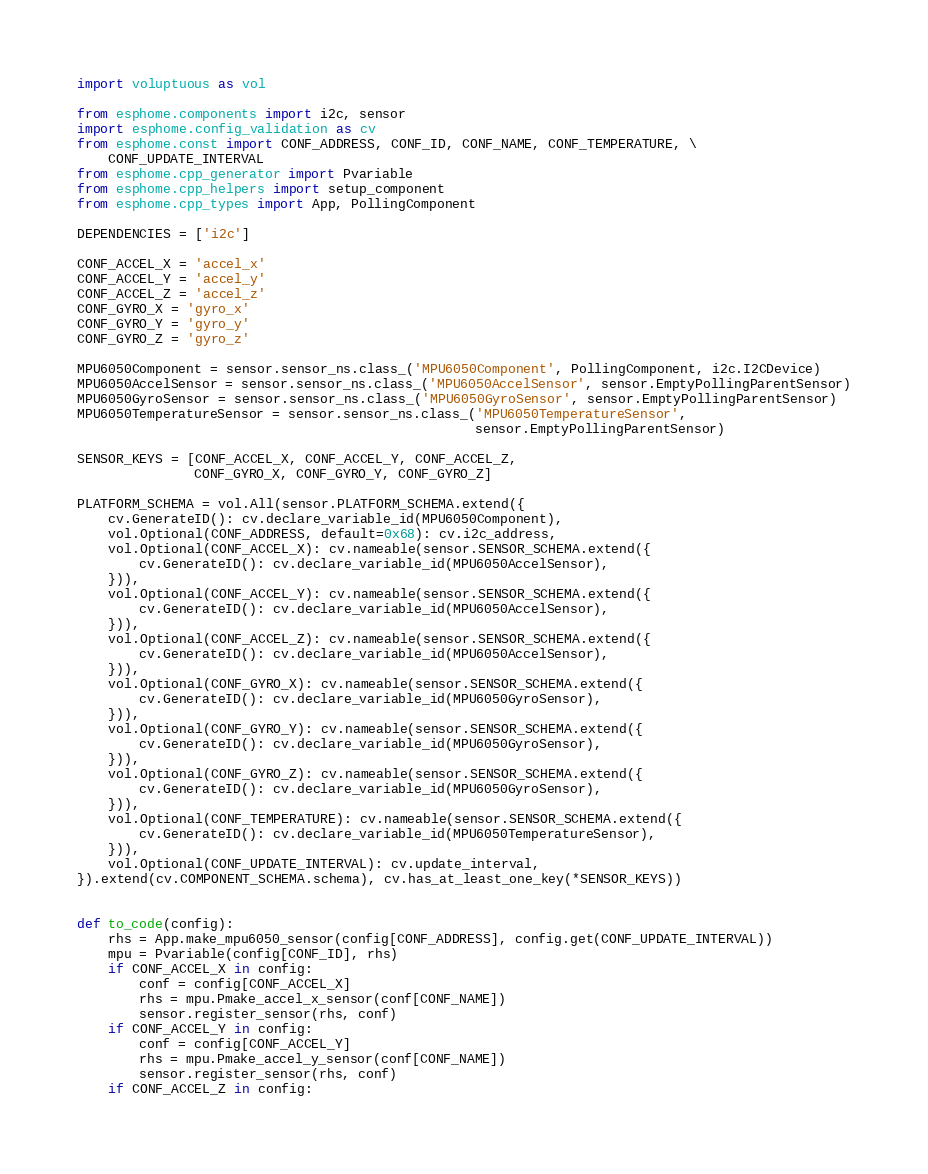<code> <loc_0><loc_0><loc_500><loc_500><_Python_>import voluptuous as vol

from esphome.components import i2c, sensor
import esphome.config_validation as cv
from esphome.const import CONF_ADDRESS, CONF_ID, CONF_NAME, CONF_TEMPERATURE, \
    CONF_UPDATE_INTERVAL
from esphome.cpp_generator import Pvariable
from esphome.cpp_helpers import setup_component
from esphome.cpp_types import App, PollingComponent

DEPENDENCIES = ['i2c']

CONF_ACCEL_X = 'accel_x'
CONF_ACCEL_Y = 'accel_y'
CONF_ACCEL_Z = 'accel_z'
CONF_GYRO_X = 'gyro_x'
CONF_GYRO_Y = 'gyro_y'
CONF_GYRO_Z = 'gyro_z'

MPU6050Component = sensor.sensor_ns.class_('MPU6050Component', PollingComponent, i2c.I2CDevice)
MPU6050AccelSensor = sensor.sensor_ns.class_('MPU6050AccelSensor', sensor.EmptyPollingParentSensor)
MPU6050GyroSensor = sensor.sensor_ns.class_('MPU6050GyroSensor', sensor.EmptyPollingParentSensor)
MPU6050TemperatureSensor = sensor.sensor_ns.class_('MPU6050TemperatureSensor',
                                                   sensor.EmptyPollingParentSensor)

SENSOR_KEYS = [CONF_ACCEL_X, CONF_ACCEL_Y, CONF_ACCEL_Z,
               CONF_GYRO_X, CONF_GYRO_Y, CONF_GYRO_Z]

PLATFORM_SCHEMA = vol.All(sensor.PLATFORM_SCHEMA.extend({
    cv.GenerateID(): cv.declare_variable_id(MPU6050Component),
    vol.Optional(CONF_ADDRESS, default=0x68): cv.i2c_address,
    vol.Optional(CONF_ACCEL_X): cv.nameable(sensor.SENSOR_SCHEMA.extend({
        cv.GenerateID(): cv.declare_variable_id(MPU6050AccelSensor),
    })),
    vol.Optional(CONF_ACCEL_Y): cv.nameable(sensor.SENSOR_SCHEMA.extend({
        cv.GenerateID(): cv.declare_variable_id(MPU6050AccelSensor),
    })),
    vol.Optional(CONF_ACCEL_Z): cv.nameable(sensor.SENSOR_SCHEMA.extend({
        cv.GenerateID(): cv.declare_variable_id(MPU6050AccelSensor),
    })),
    vol.Optional(CONF_GYRO_X): cv.nameable(sensor.SENSOR_SCHEMA.extend({
        cv.GenerateID(): cv.declare_variable_id(MPU6050GyroSensor),
    })),
    vol.Optional(CONF_GYRO_Y): cv.nameable(sensor.SENSOR_SCHEMA.extend({
        cv.GenerateID(): cv.declare_variable_id(MPU6050GyroSensor),
    })),
    vol.Optional(CONF_GYRO_Z): cv.nameable(sensor.SENSOR_SCHEMA.extend({
        cv.GenerateID(): cv.declare_variable_id(MPU6050GyroSensor),
    })),
    vol.Optional(CONF_TEMPERATURE): cv.nameable(sensor.SENSOR_SCHEMA.extend({
        cv.GenerateID(): cv.declare_variable_id(MPU6050TemperatureSensor),
    })),
    vol.Optional(CONF_UPDATE_INTERVAL): cv.update_interval,
}).extend(cv.COMPONENT_SCHEMA.schema), cv.has_at_least_one_key(*SENSOR_KEYS))


def to_code(config):
    rhs = App.make_mpu6050_sensor(config[CONF_ADDRESS], config.get(CONF_UPDATE_INTERVAL))
    mpu = Pvariable(config[CONF_ID], rhs)
    if CONF_ACCEL_X in config:
        conf = config[CONF_ACCEL_X]
        rhs = mpu.Pmake_accel_x_sensor(conf[CONF_NAME])
        sensor.register_sensor(rhs, conf)
    if CONF_ACCEL_Y in config:
        conf = config[CONF_ACCEL_Y]
        rhs = mpu.Pmake_accel_y_sensor(conf[CONF_NAME])
        sensor.register_sensor(rhs, conf)
    if CONF_ACCEL_Z in config:</code> 